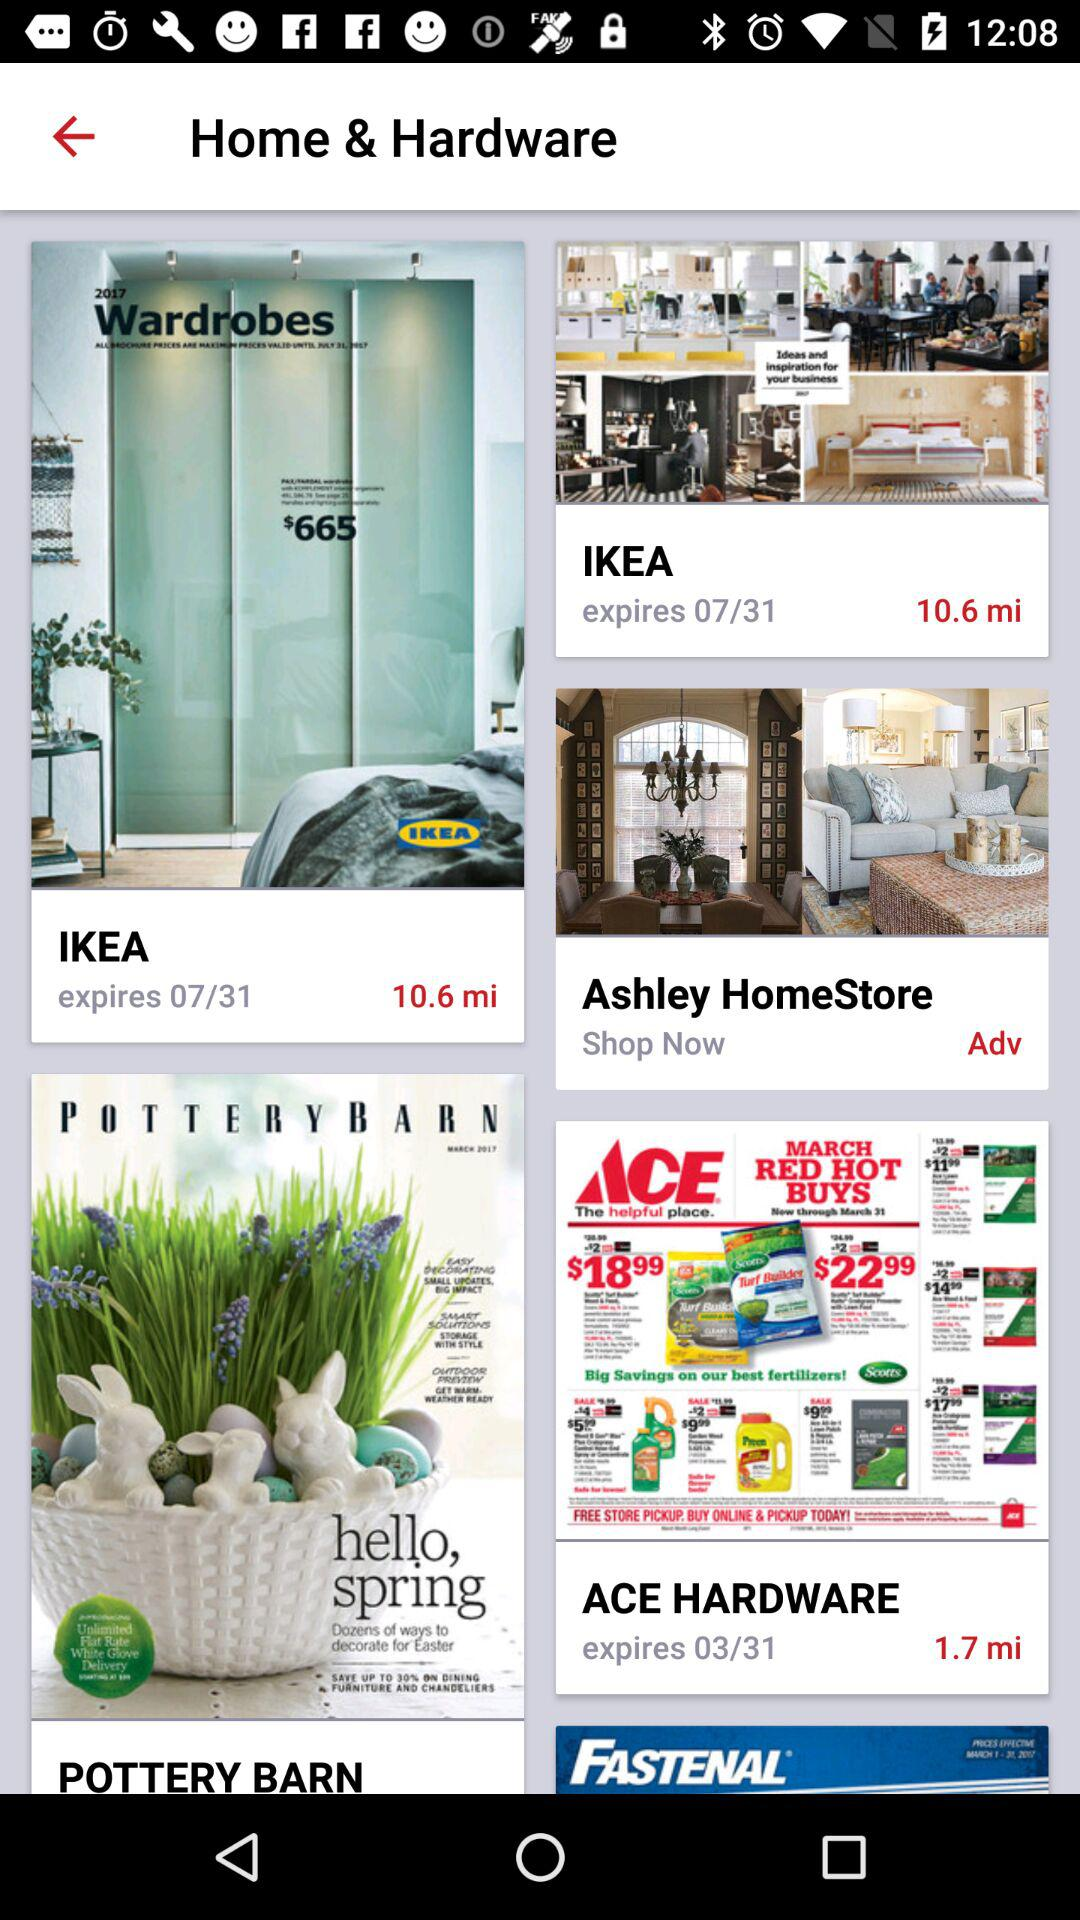How far is it to "ACE HARDWARE"? It is 1.7 miles away. 